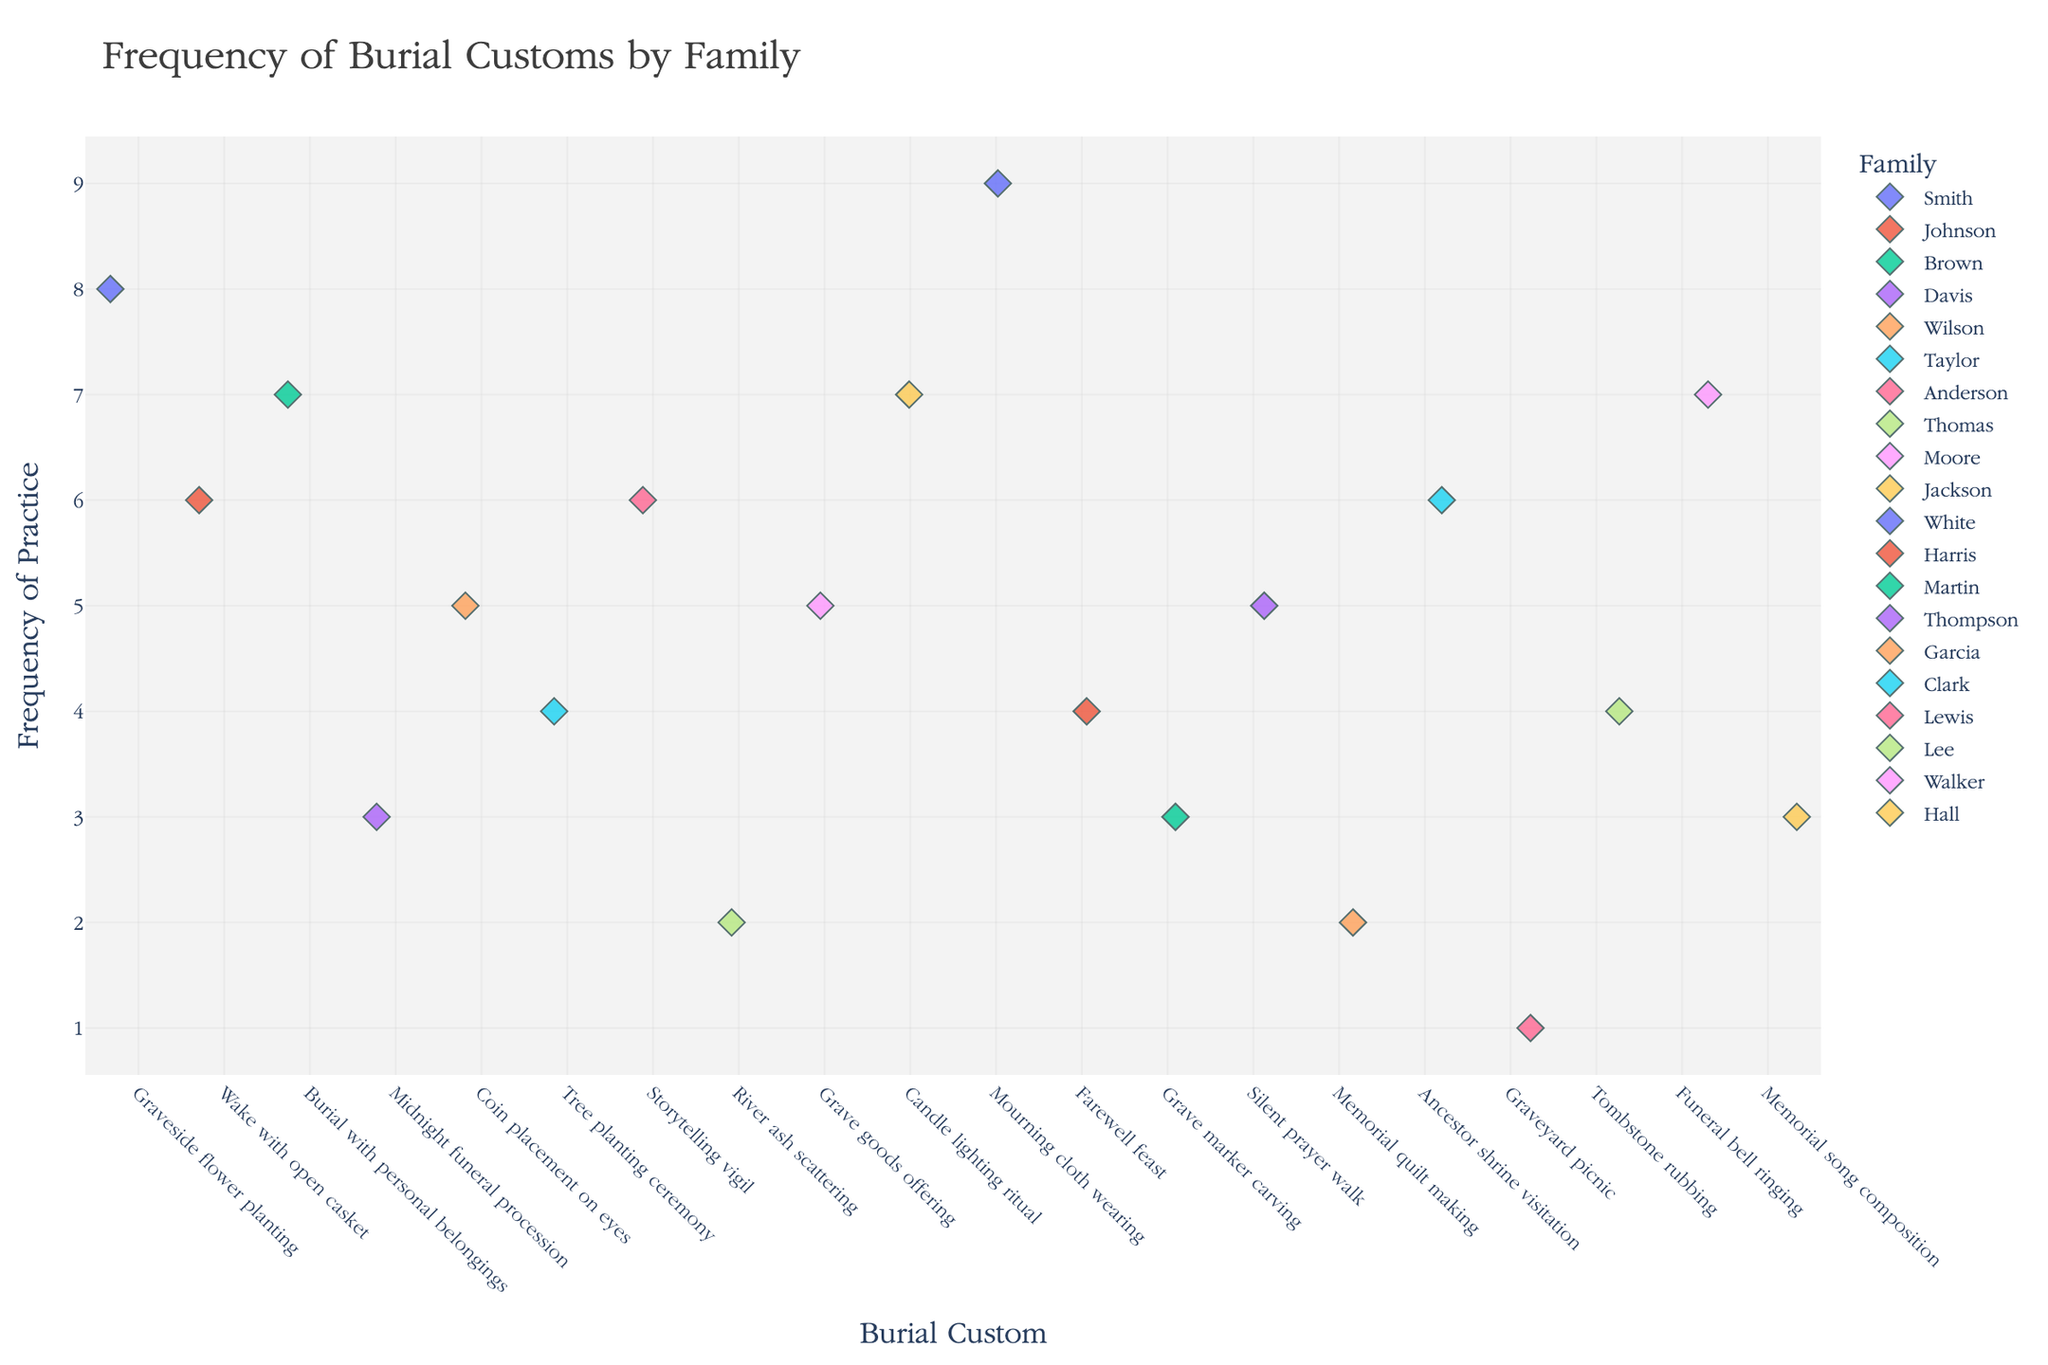What's the title of the plot? The title is usually located at the top of the plot and summarizes what the figure is about.
Answer: Frequency of Burial Customs by Family How many families practiced the "Coin placement on eyes" custom? Look for the "Coin placement on eyes" custom on the x-axis, then count the number of points associated with that custom.
Answer: 1 Which family practices the "Mourning cloth wearing" custom, and how frequently? Locate the "Mourning cloth wearing" custom on the x-axis and then identify the single point and the corresponding family from the color legend. The y-axis shows the frequency.
Answer: White, 9 What is the combined frequency for "Grave goods offering" and "Memorial quilt making"? Find the frequencies of both customs on the y-axis, then add them together: "Grave goods offering" is 5 and "Memorial quilt making" is 2.
Answer: 7 Which burial custom has the highest frequency, and which family practices it? Identify the tallest point on the y-axis and note the corresponding custom and family from the color legend.
Answer: Mourning cloth wearing, White How many families practice customs with a frequency of 4? Look at the y-axis for the frequency value of 4 and count the number of unique points on the plot corresponding to this frequency.
Answer: 4 Is there any custom practiced by the same number of families as the "Silent prayer walk"? Which custom is it? Look for points at the same height on the y-axis as "Silent prayer walk" and identify similar frequency counts. Count the points for each custom and find the matching custom.
Answer: Coin placement on eyes What is the average frequency of burial customs practiced by the Smith family and the Jackson family? First, find the frequencies for each family (Smith: 8, Jackson: 7), then calculate the average: (8 + 7) / 2.
Answer: 7.5 Which has more frequent practice: "Wake with open casket" or "Farewell feast"? Find the frequencies on the y-axis for both customs and compare them. "Wake with open casket" is 6, and "Farewell feast" is 4.
Answer: Wake with open casket Are there any burial customs practiced by more than one family? Count the points for each burial custom, and determine if any customs have more than one point, indicating multiple families.
Answer: No 